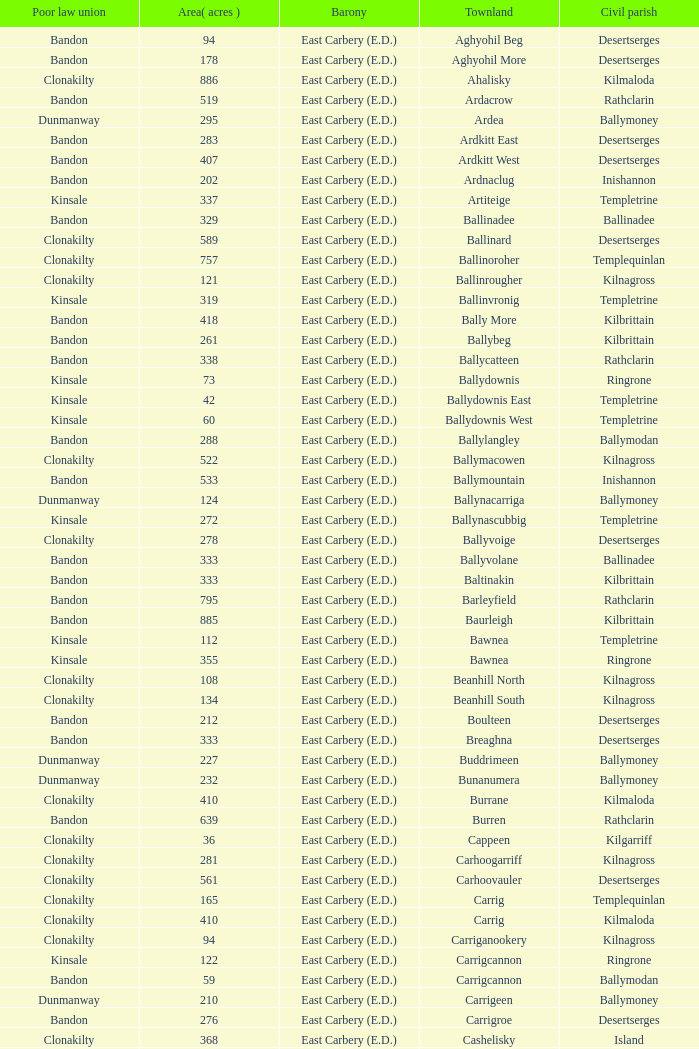What is the poor law union of the Lackenagobidane townland? Clonakilty. 